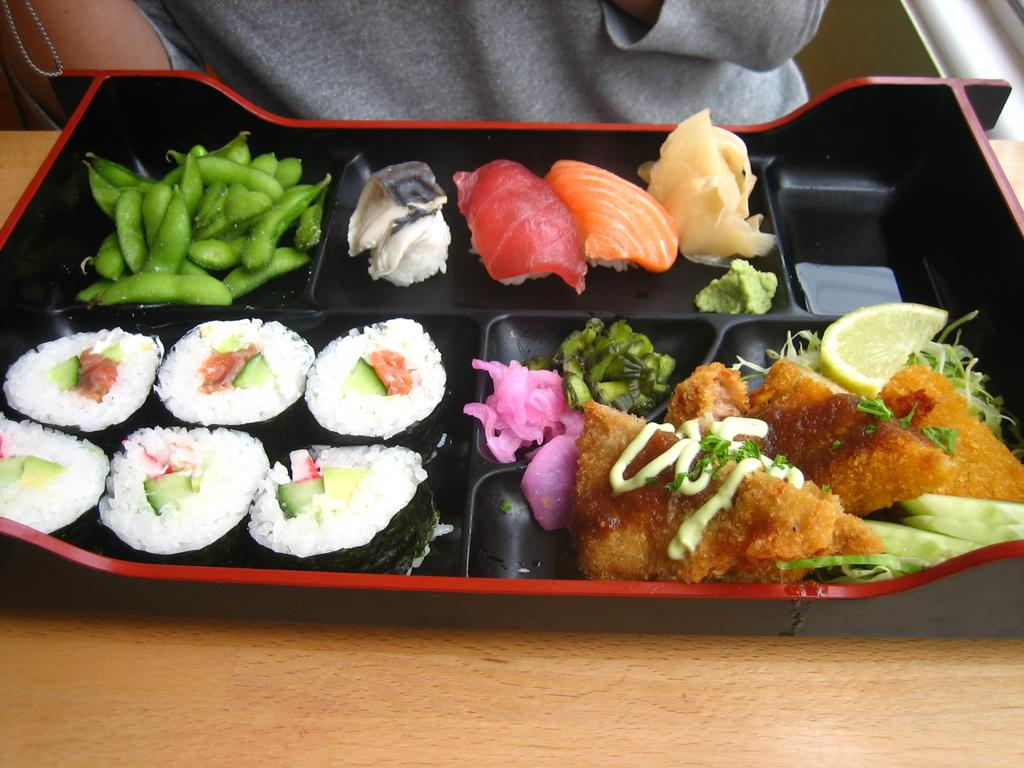What is on the tray that is visible in the image? There are food items on a tray in the image. Where is the tray located in the image? The tray is placed on a table in the image. Can you describe the person in the background of the image? The provided facts do not give any information about the person in the background, so we cannot describe them. What holiday is being celebrated in the image? There is no information about a holiday in the image or the provided facts. --- Facts: 1. There is a person holding a book in the image. 2. The person is sitting on a chair. 3. The chair is in front of a desk. 4. There is a lamp on the desk. Absurd Topics: ocean, dance, parrot Conversation: What is the person in the image holding? The person in the image is holding a book. What is the person's position in the image? The person is sitting on a chair. Where is the chair located in the image? The chair is in front of a desk. What is on the desk in the image? There is a lamp on the desk. Reasoning: Let's think step by step in order to produce the conversation. We start by identifying the main subject in the image, which is the person holding a book. Then, we expand the conversation to include the person's position (sitting on a chair) and the location of the chair (in front of a desk). Finally, we describe the object on the desk, which is a lamp. Absurd Question/Answer: Can you see any parrots in the image? There are no parrots present in the image. 